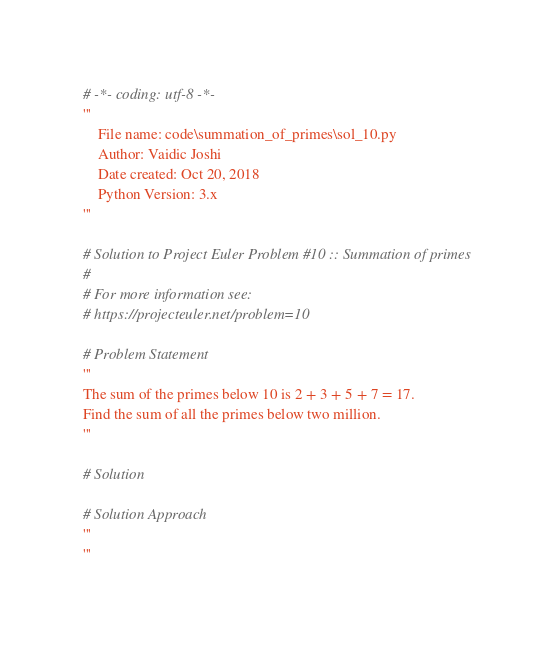Convert code to text. <code><loc_0><loc_0><loc_500><loc_500><_Python_>
# -*- coding: utf-8 -*-
'''
    File name: code\summation_of_primes\sol_10.py
    Author: Vaidic Joshi
    Date created: Oct 20, 2018
    Python Version: 3.x
'''

# Solution to Project Euler Problem #10 :: Summation of primes
# 
# For more information see:
# https://projecteuler.net/problem=10

# Problem Statement 
'''
The sum of the primes below 10 is 2 + 3 + 5 + 7 = 17.
Find the sum of all the primes below two million.
'''

# Solution 

# Solution Approach 
'''
'''
</code> 